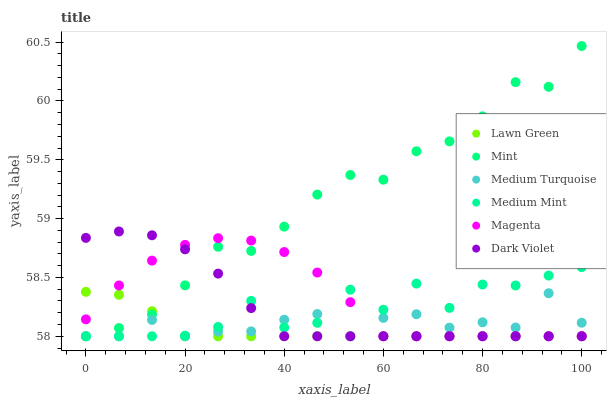Does Lawn Green have the minimum area under the curve?
Answer yes or no. Yes. Does Mint have the maximum area under the curve?
Answer yes or no. Yes. Does Dark Violet have the minimum area under the curve?
Answer yes or no. No. Does Dark Violet have the maximum area under the curve?
Answer yes or no. No. Is Lawn Green the smoothest?
Answer yes or no. Yes. Is Medium Mint the roughest?
Answer yes or no. Yes. Is Dark Violet the smoothest?
Answer yes or no. No. Is Dark Violet the roughest?
Answer yes or no. No. Does Medium Mint have the lowest value?
Answer yes or no. Yes. Does Mint have the highest value?
Answer yes or no. Yes. Does Lawn Green have the highest value?
Answer yes or no. No. Does Dark Violet intersect Mint?
Answer yes or no. Yes. Is Dark Violet less than Mint?
Answer yes or no. No. Is Dark Violet greater than Mint?
Answer yes or no. No. 